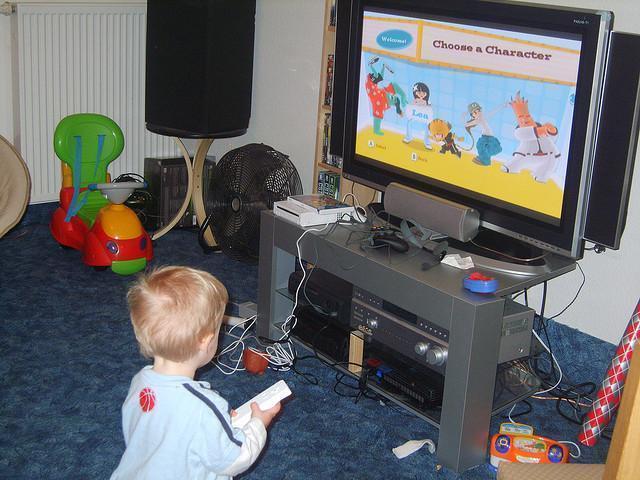Which character has been selected?
Select the correct answer and articulate reasoning with the following format: 'Answer: answer
Rationale: rationale.'
Options: Fifth, fourth, second, first. Answer: second.
Rationale: A child is pointing an remote towards the television and the second person on the screen is highlighted. 